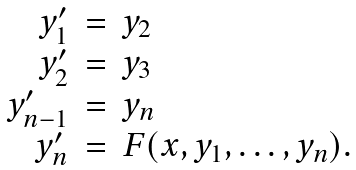<formula> <loc_0><loc_0><loc_500><loc_500>\begin{array} { r c l } { y _ { 1 } ^ { \prime } } & { = } & { y _ { 2 } } \\ { y _ { 2 } ^ { \prime } } & { = } & { y _ { 3 } } \\ { y _ { n - 1 } ^ { \prime } } & { = } & { y _ { n } } \\ { y _ { n } ^ { \prime } } & { = } & { F ( x , y _ { 1 } , \dots , y _ { n } ) . } \end{array}</formula> 